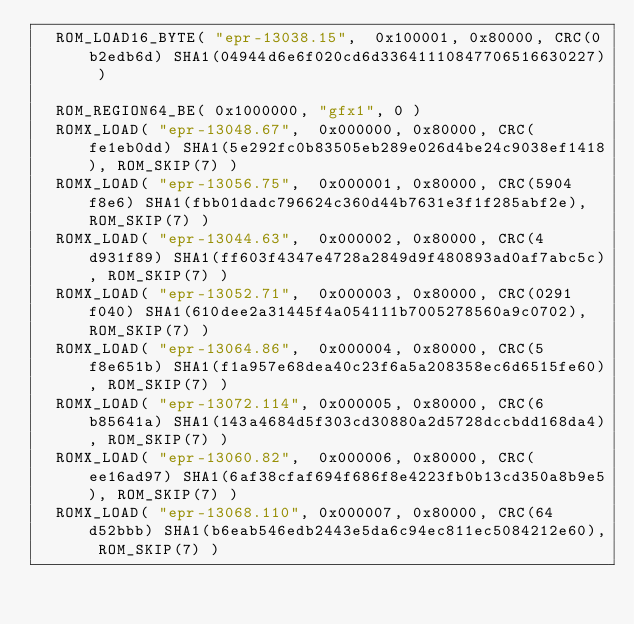Convert code to text. <code><loc_0><loc_0><loc_500><loc_500><_C_>	ROM_LOAD16_BYTE( "epr-13038.15",  0x100001, 0x80000, CRC(0b2edb6d) SHA1(04944d6e6f020cd6d33641110847706516630227) )

	ROM_REGION64_BE( 0x1000000, "gfx1", 0 )
	ROMX_LOAD( "epr-13048.67",  0x000000, 0x80000, CRC(fe1eb0dd) SHA1(5e292fc0b83505eb289e026d4be24c9038ef1418), ROM_SKIP(7) )
	ROMX_LOAD( "epr-13056.75",  0x000001, 0x80000, CRC(5904f8e6) SHA1(fbb01dadc796624c360d44b7631e3f1f285abf2e), ROM_SKIP(7) )
	ROMX_LOAD( "epr-13044.63",  0x000002, 0x80000, CRC(4d931f89) SHA1(ff603f4347e4728a2849d9f480893ad0af7abc5c), ROM_SKIP(7) )
	ROMX_LOAD( "epr-13052.71",  0x000003, 0x80000, CRC(0291f040) SHA1(610dee2a31445f4a054111b7005278560a9c0702), ROM_SKIP(7) )
	ROMX_LOAD( "epr-13064.86",  0x000004, 0x80000, CRC(5f8e651b) SHA1(f1a957e68dea40c23f6a5a208358ec6d6515fe60), ROM_SKIP(7) )
	ROMX_LOAD( "epr-13072.114", 0x000005, 0x80000, CRC(6b85641a) SHA1(143a4684d5f303cd30880a2d5728dccbdd168da4), ROM_SKIP(7) )
	ROMX_LOAD( "epr-13060.82",  0x000006, 0x80000, CRC(ee16ad97) SHA1(6af38cfaf694f686f8e4223fb0b13cd350a8b9e5), ROM_SKIP(7) )
	ROMX_LOAD( "epr-13068.110", 0x000007, 0x80000, CRC(64d52bbb) SHA1(b6eab546edb2443e5da6c94ec811ec5084212e60), ROM_SKIP(7) )
</code> 